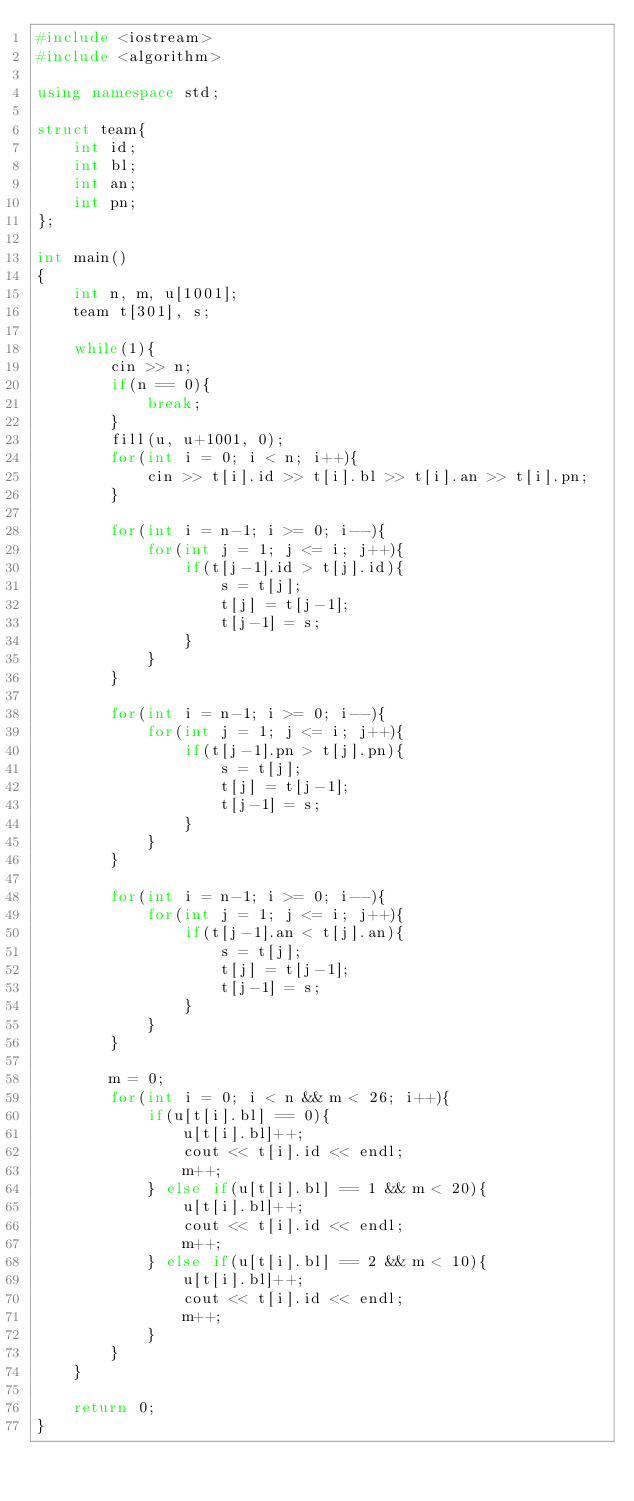<code> <loc_0><loc_0><loc_500><loc_500><_C++_>#include <iostream>
#include <algorithm>

using namespace std;

struct team{
	int id;
	int bl;
	int an;
	int pn;
};

int main()
{
	int n, m, u[1001];
	team t[301], s;
	
	while(1){
		cin >> n;
		if(n == 0){
			break;
		}
		fill(u, u+1001, 0);
		for(int i = 0; i < n; i++){
			cin >> t[i].id >> t[i].bl >> t[i].an >> t[i].pn;
		}
		
		for(int i = n-1; i >= 0; i--){
			for(int j = 1; j <= i; j++){
				if(t[j-1].id > t[j].id){
					s = t[j];
					t[j] = t[j-1];
					t[j-1] = s;
				}
			}
		}
		
		for(int i = n-1; i >= 0; i--){
			for(int j = 1; j <= i; j++){
				if(t[j-1].pn > t[j].pn){
					s = t[j];
					t[j] = t[j-1];
					t[j-1] = s;
				}
			}
		}
		
		for(int i = n-1; i >= 0; i--){
			for(int j = 1; j <= i; j++){
				if(t[j-1].an < t[j].an){
					s = t[j];
					t[j] = t[j-1];
					t[j-1] = s;
				}
			}
		}
		
		m = 0;
		for(int i = 0; i < n && m < 26; i++){
			if(u[t[i].bl] == 0){
				u[t[i].bl]++;
				cout << t[i].id << endl;
				m++;
			} else if(u[t[i].bl] == 1 && m < 20){
				u[t[i].bl]++;
				cout << t[i].id << endl;
				m++;
			} else if(u[t[i].bl] == 2 && m < 10){
				u[t[i].bl]++;
				cout << t[i].id << endl;
				m++;
			}
		}
	}
	
	return 0;
}</code> 